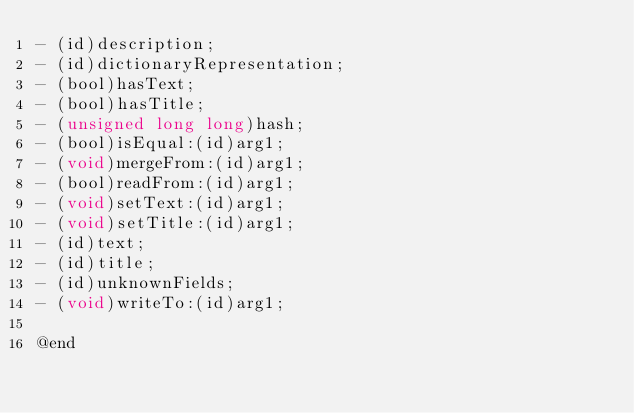Convert code to text. <code><loc_0><loc_0><loc_500><loc_500><_C_>- (id)description;
- (id)dictionaryRepresentation;
- (bool)hasText;
- (bool)hasTitle;
- (unsigned long long)hash;
- (bool)isEqual:(id)arg1;
- (void)mergeFrom:(id)arg1;
- (bool)readFrom:(id)arg1;
- (void)setText:(id)arg1;
- (void)setTitle:(id)arg1;
- (id)text;
- (id)title;
- (id)unknownFields;
- (void)writeTo:(id)arg1;

@end
</code> 